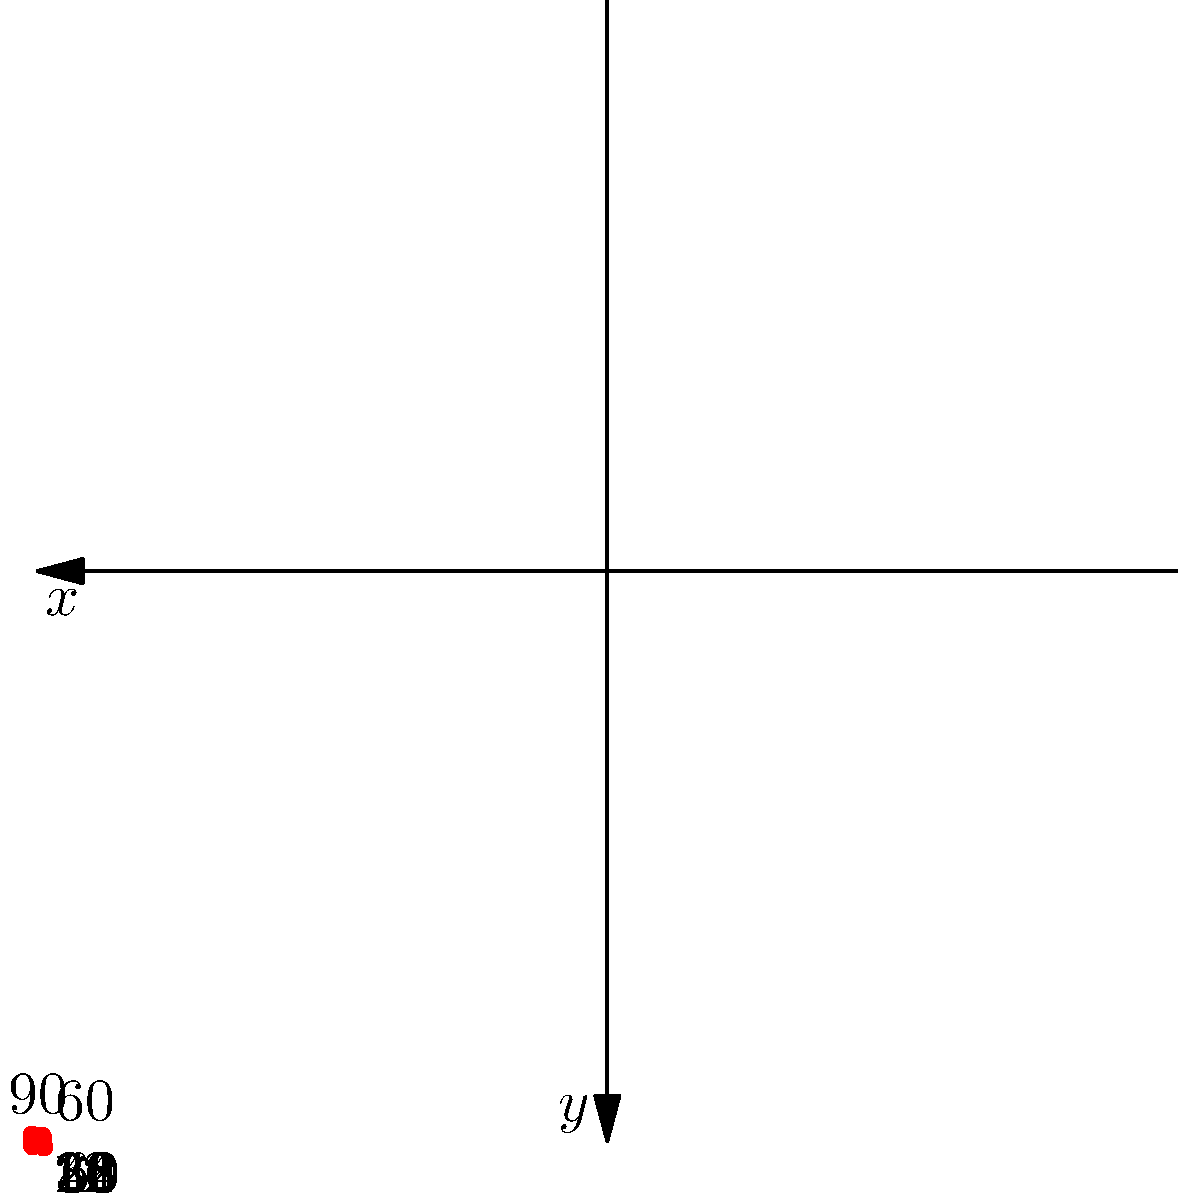As a UX designer for an automotive navigation system, you're working on a feature that plots waypoints on a polar grid. The system has recorded 8 waypoints at different angles and distances from the origin. If the grid represents a 60-mile radius, what is the total distance traveled between all consecutive waypoints, assuming the vehicle moves in straight lines between each point? To solve this problem, we need to follow these steps:

1. Identify the coordinates of each waypoint in polar form $(r, \theta)$:
   $(30, 0°)$, $(40, 45°)$, $(20, 90°)$, $(50, 135°)$, $(35, 180°)$, $(45, 225°)$, $(25, 270°)$, $(55, 315°)$

2. Convert polar coordinates to Cartesian coordinates $(x, y)$ using:
   $x = r \cos(\theta)$, $y = r \sin(\theta)$

3. Calculate the distance between consecutive points using the distance formula:
   $d = \sqrt{(x_2 - x_1)^2 + (y_2 - y_1)^2}$

4. Sum up all the distances

Step 2: Converting to Cartesian coordinates
1. $(30, 0)$
2. $(40 \cos(45°), 40 \sin(45°)) \approx (28.28, 28.28)$
3. $(0, 20)$
4. $(-50 \cos(45°), 50 \sin(45°)) \approx (-35.36, 35.36)$
5. $(-35, 0)$
6. $(-45 \cos(45°), -45 \sin(45°)) \approx (-31.82, -31.82)$
7. $(0, -25)$
8. $(55 \cos(45°), -55 \sin(45°)) \approx (38.89, -38.89)$

Step 3 & 4: Calculating and summing distances
1. From 1 to 2: $\sqrt{(28.28 - 30)^2 + (28.28 - 0)^2} \approx 28.46$
2. From 2 to 3: $\sqrt{(0 - 28.28)^2 + (20 - 28.28)^2} \approx 30.41$
3. From 3 to 4: $\sqrt{(-35.36 - 0)^2 + (35.36 - 20)^2} \approx 39.05$
4. From 4 to 5: $\sqrt{(-35 - (-35.36))^2 + (0 - 35.36)^2} \approx 35.37$
5. From 5 to 6: $\sqrt{(-31.82 - (-35))^2 + (-31.82 - 0)^2} \approx 32.70$
6. From 6 to 7: $\sqrt{(0 - (-31.82))^2 + (-25 - (-31.82))^2} \approx 33.54$
7. From 7 to 8: $\sqrt{(38.89 - 0)^2 + (-38.89 - (-25))^2} \approx 42.43$
8. From 8 to 1 (to complete the loop): $\sqrt{(30 - 38.89)^2 + (0 - (-38.89))^2} \approx 39.72$

Total distance: $28.46 + 30.41 + 39.05 + 35.37 + 32.70 + 33.54 + 42.43 + 39.72 \approx 281.68$ miles
Answer: 281.68 miles 